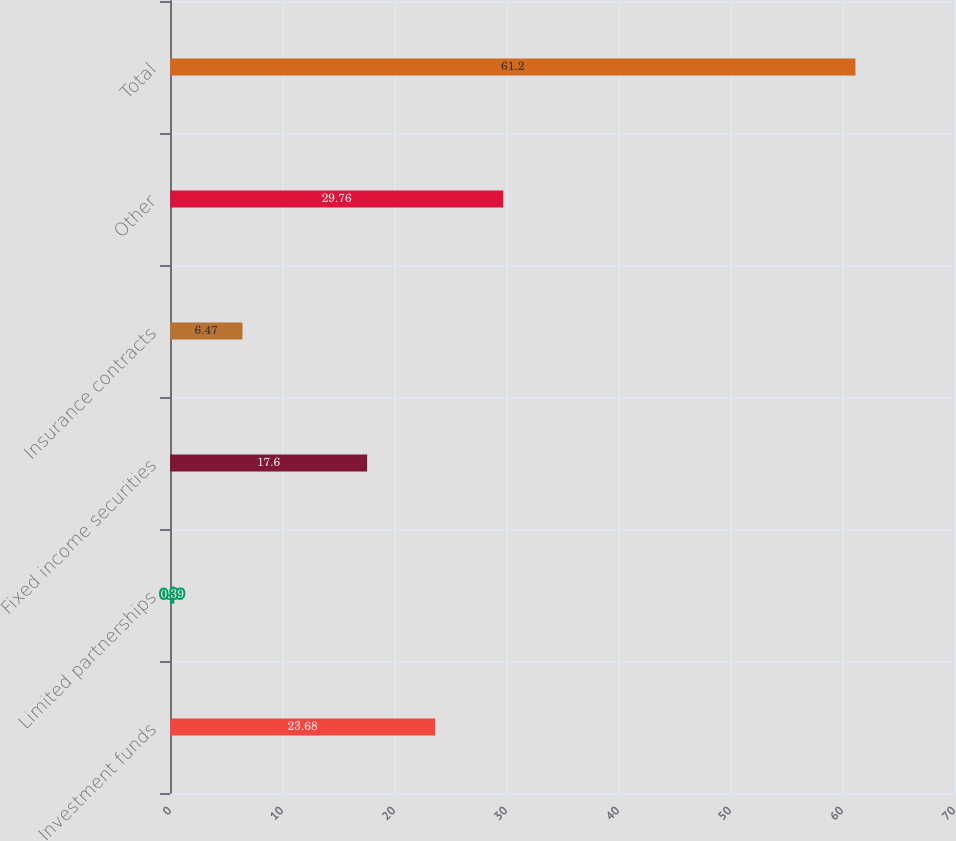Convert chart. <chart><loc_0><loc_0><loc_500><loc_500><bar_chart><fcel>Investment funds<fcel>Limited partnerships<fcel>Fixed income securities<fcel>Insurance contracts<fcel>Other<fcel>Total<nl><fcel>23.68<fcel>0.39<fcel>17.6<fcel>6.47<fcel>29.76<fcel>61.2<nl></chart> 